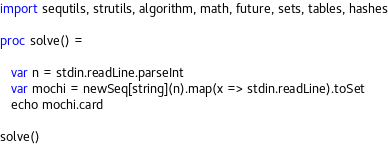Convert code to text. <code><loc_0><loc_0><loc_500><loc_500><_Nim_>import sequtils, strutils, algorithm, math, future, sets, tables, hashes

proc solve() =
   
   var n = stdin.readLine.parseInt
   var mochi = newSeq[string](n).map(x => stdin.readLine).toSet
   echo mochi.card

solve()</code> 